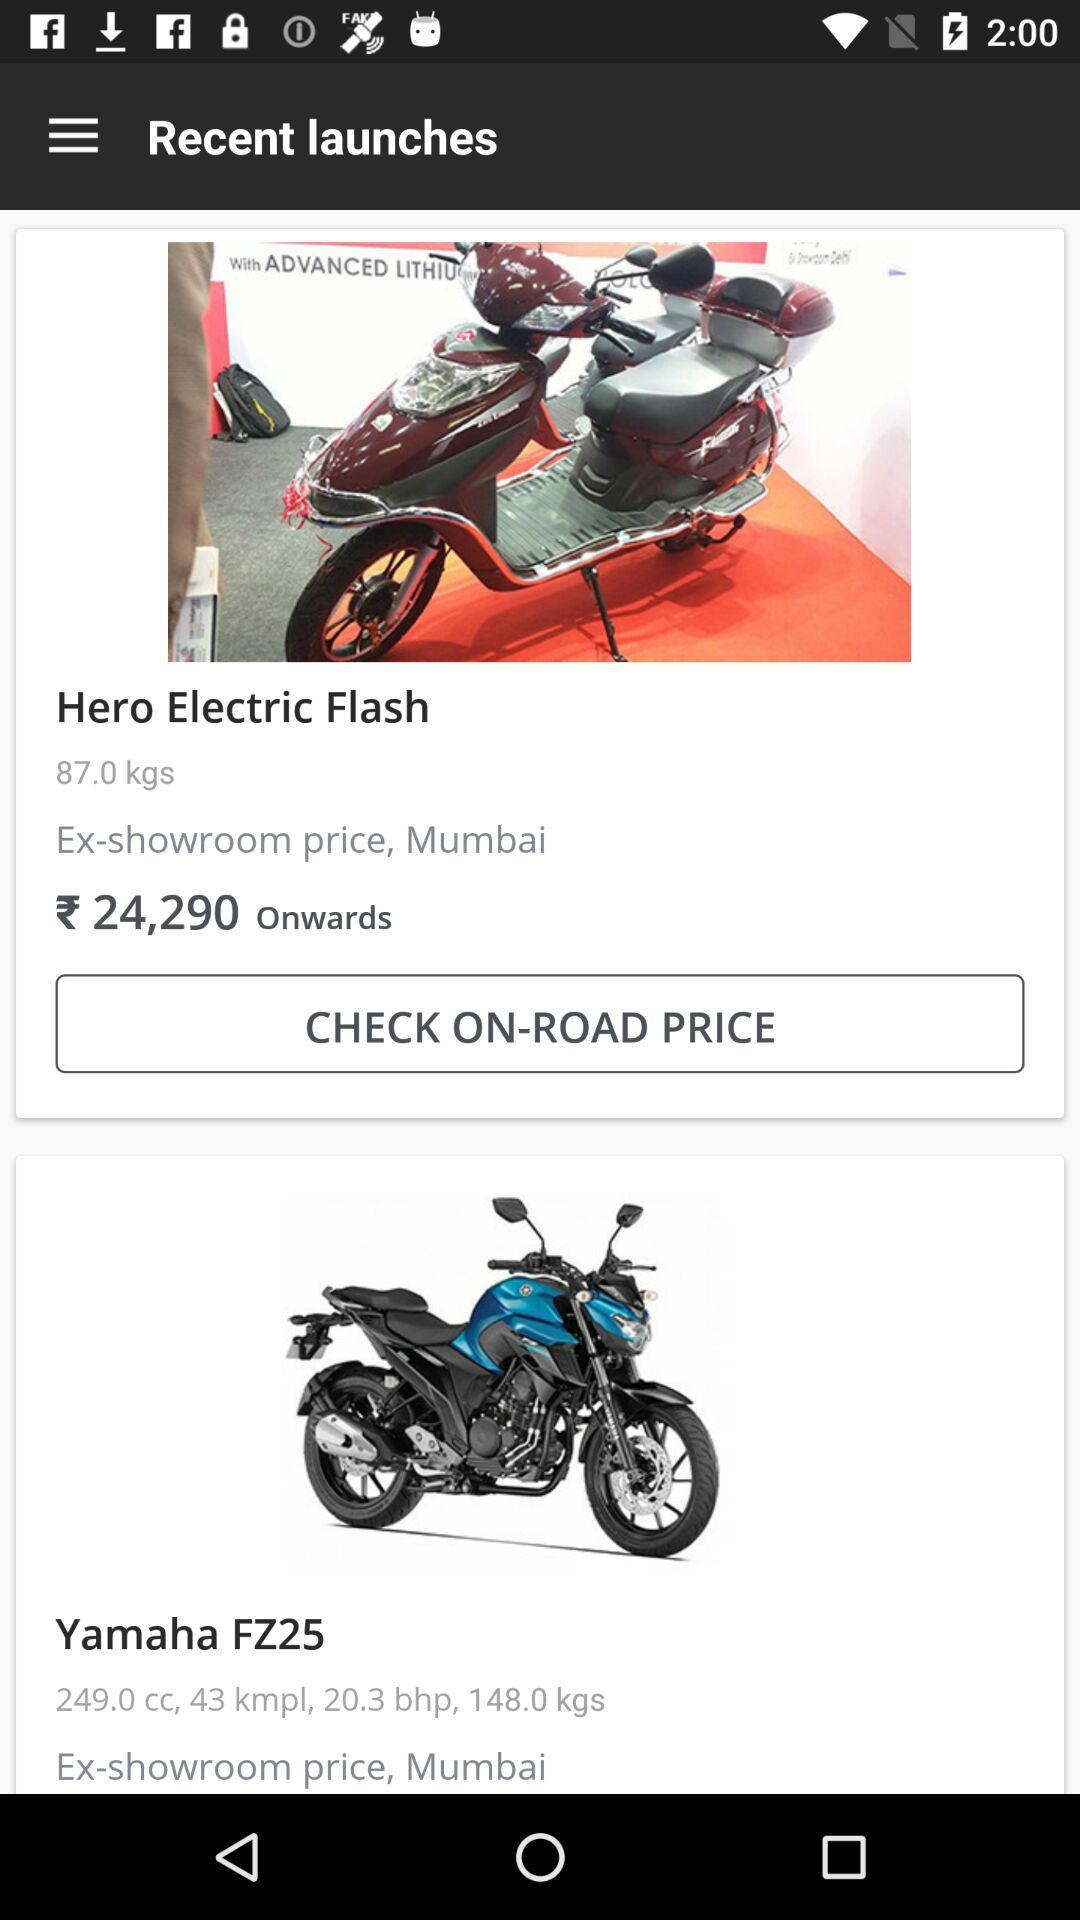What is the weight of "Hero Electric Flash"? The weight of "Hero Electric Flash" is 87.0 kg. 